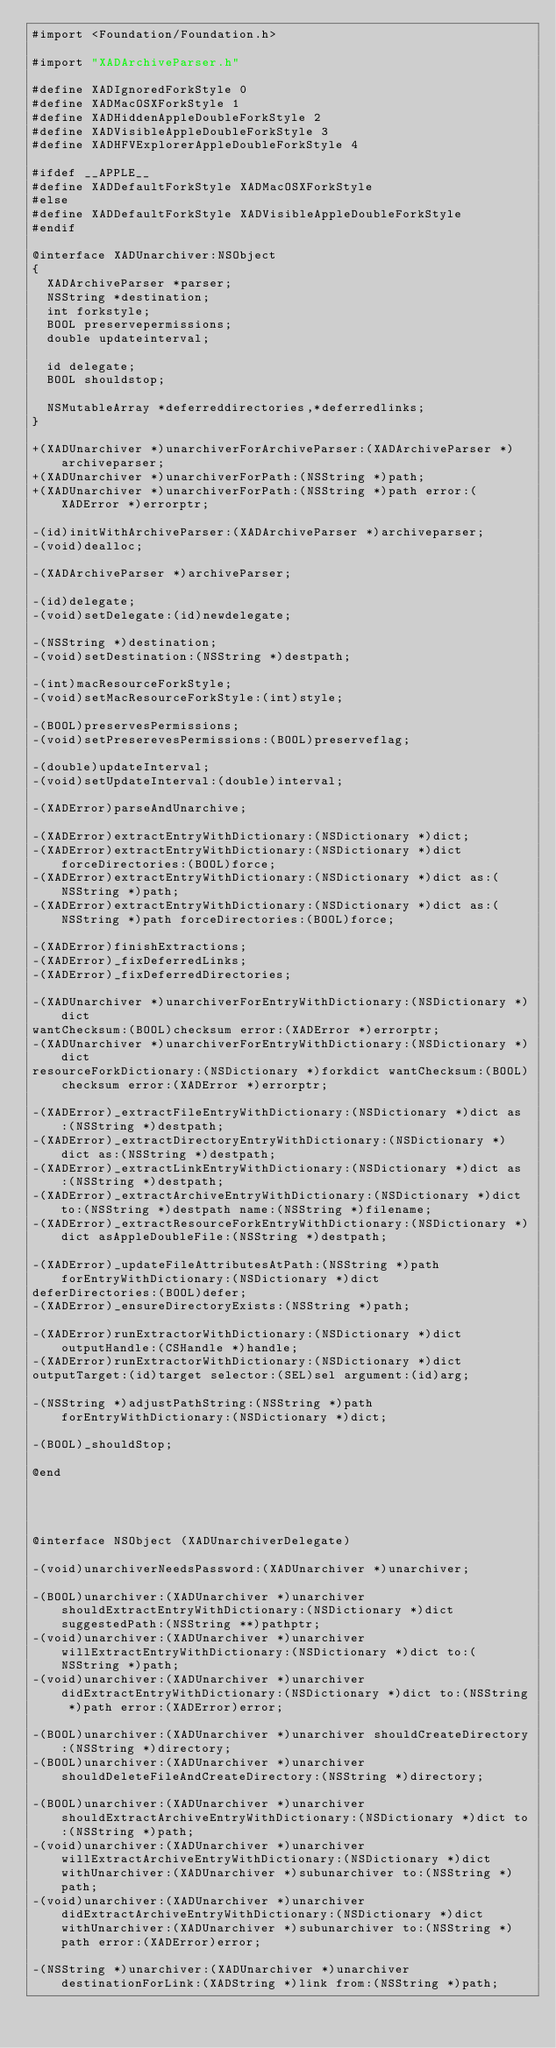Convert code to text. <code><loc_0><loc_0><loc_500><loc_500><_C_>#import <Foundation/Foundation.h>

#import "XADArchiveParser.h"

#define XADIgnoredForkStyle 0
#define XADMacOSXForkStyle 1
#define XADHiddenAppleDoubleForkStyle 2
#define XADVisibleAppleDoubleForkStyle 3
#define XADHFVExplorerAppleDoubleForkStyle 4

#ifdef __APPLE__
#define XADDefaultForkStyle XADMacOSXForkStyle
#else
#define XADDefaultForkStyle XADVisibleAppleDoubleForkStyle
#endif

@interface XADUnarchiver:NSObject
{
	XADArchiveParser *parser;
	NSString *destination;
	int forkstyle;
	BOOL preservepermissions;
	double updateinterval;

	id delegate;
	BOOL shouldstop;

	NSMutableArray *deferreddirectories,*deferredlinks;
}

+(XADUnarchiver *)unarchiverForArchiveParser:(XADArchiveParser *)archiveparser;
+(XADUnarchiver *)unarchiverForPath:(NSString *)path;
+(XADUnarchiver *)unarchiverForPath:(NSString *)path error:(XADError *)errorptr;

-(id)initWithArchiveParser:(XADArchiveParser *)archiveparser;
-(void)dealloc;

-(XADArchiveParser *)archiveParser;

-(id)delegate;
-(void)setDelegate:(id)newdelegate;

-(NSString *)destination;
-(void)setDestination:(NSString *)destpath;

-(int)macResourceForkStyle;
-(void)setMacResourceForkStyle:(int)style;

-(BOOL)preservesPermissions;
-(void)setPreserevesPermissions:(BOOL)preserveflag;

-(double)updateInterval;
-(void)setUpdateInterval:(double)interval;

-(XADError)parseAndUnarchive;

-(XADError)extractEntryWithDictionary:(NSDictionary *)dict;
-(XADError)extractEntryWithDictionary:(NSDictionary *)dict forceDirectories:(BOOL)force;
-(XADError)extractEntryWithDictionary:(NSDictionary *)dict as:(NSString *)path;
-(XADError)extractEntryWithDictionary:(NSDictionary *)dict as:(NSString *)path forceDirectories:(BOOL)force;

-(XADError)finishExtractions;
-(XADError)_fixDeferredLinks;
-(XADError)_fixDeferredDirectories;

-(XADUnarchiver *)unarchiverForEntryWithDictionary:(NSDictionary *)dict
wantChecksum:(BOOL)checksum error:(XADError *)errorptr;
-(XADUnarchiver *)unarchiverForEntryWithDictionary:(NSDictionary *)dict
resourceForkDictionary:(NSDictionary *)forkdict wantChecksum:(BOOL)checksum error:(XADError *)errorptr;

-(XADError)_extractFileEntryWithDictionary:(NSDictionary *)dict as:(NSString *)destpath;
-(XADError)_extractDirectoryEntryWithDictionary:(NSDictionary *)dict as:(NSString *)destpath;
-(XADError)_extractLinkEntryWithDictionary:(NSDictionary *)dict as:(NSString *)destpath;
-(XADError)_extractArchiveEntryWithDictionary:(NSDictionary *)dict to:(NSString *)destpath name:(NSString *)filename;
-(XADError)_extractResourceForkEntryWithDictionary:(NSDictionary *)dict asAppleDoubleFile:(NSString *)destpath;

-(XADError)_updateFileAttributesAtPath:(NSString *)path forEntryWithDictionary:(NSDictionary *)dict
deferDirectories:(BOOL)defer;
-(XADError)_ensureDirectoryExists:(NSString *)path;

-(XADError)runExtractorWithDictionary:(NSDictionary *)dict outputHandle:(CSHandle *)handle;
-(XADError)runExtractorWithDictionary:(NSDictionary *)dict
outputTarget:(id)target selector:(SEL)sel argument:(id)arg;

-(NSString *)adjustPathString:(NSString *)path forEntryWithDictionary:(NSDictionary *)dict;

-(BOOL)_shouldStop;

@end




@interface NSObject (XADUnarchiverDelegate)

-(void)unarchiverNeedsPassword:(XADUnarchiver *)unarchiver;

-(BOOL)unarchiver:(XADUnarchiver *)unarchiver shouldExtractEntryWithDictionary:(NSDictionary *)dict suggestedPath:(NSString **)pathptr;
-(void)unarchiver:(XADUnarchiver *)unarchiver willExtractEntryWithDictionary:(NSDictionary *)dict to:(NSString *)path;
-(void)unarchiver:(XADUnarchiver *)unarchiver didExtractEntryWithDictionary:(NSDictionary *)dict to:(NSString *)path error:(XADError)error;

-(BOOL)unarchiver:(XADUnarchiver *)unarchiver shouldCreateDirectory:(NSString *)directory;
-(BOOL)unarchiver:(XADUnarchiver *)unarchiver shouldDeleteFileAndCreateDirectory:(NSString *)directory;

-(BOOL)unarchiver:(XADUnarchiver *)unarchiver shouldExtractArchiveEntryWithDictionary:(NSDictionary *)dict to:(NSString *)path;
-(void)unarchiver:(XADUnarchiver *)unarchiver willExtractArchiveEntryWithDictionary:(NSDictionary *)dict withUnarchiver:(XADUnarchiver *)subunarchiver to:(NSString *)path;
-(void)unarchiver:(XADUnarchiver *)unarchiver didExtractArchiveEntryWithDictionary:(NSDictionary *)dict withUnarchiver:(XADUnarchiver *)subunarchiver to:(NSString *)path error:(XADError)error;

-(NSString *)unarchiver:(XADUnarchiver *)unarchiver destinationForLink:(XADString *)link from:(NSString *)path;
</code> 